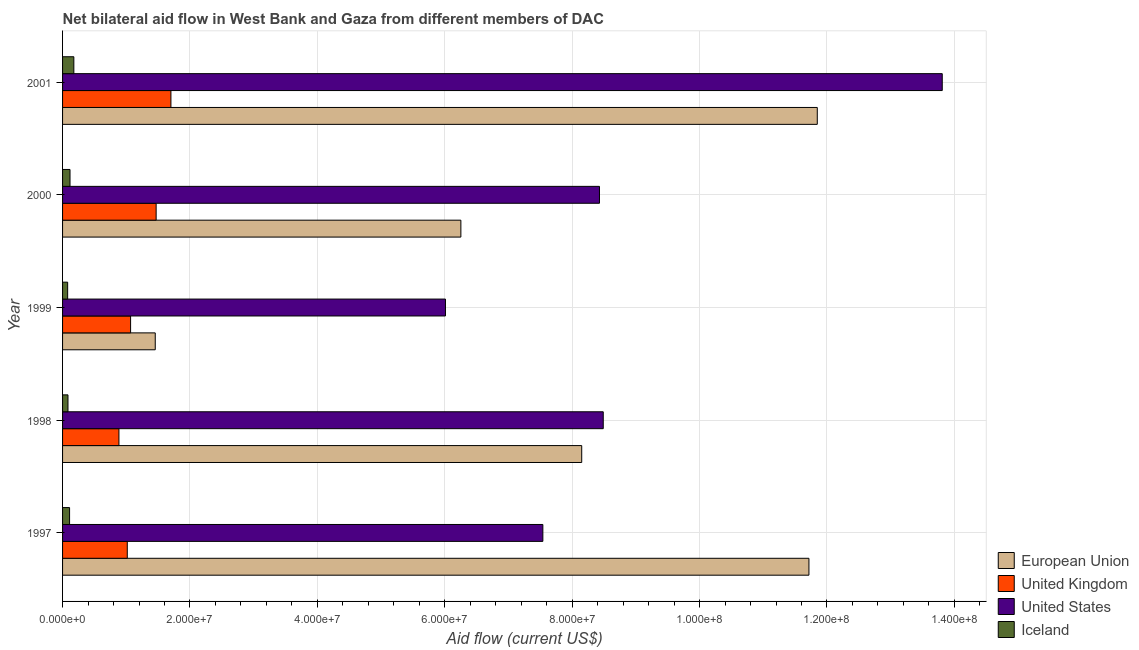In how many cases, is the number of bars for a given year not equal to the number of legend labels?
Keep it short and to the point. 0. What is the amount of aid given by us in 2000?
Provide a short and direct response. 8.43e+07. Across all years, what is the maximum amount of aid given by eu?
Make the answer very short. 1.18e+08. Across all years, what is the minimum amount of aid given by uk?
Make the answer very short. 8.85e+06. In which year was the amount of aid given by iceland maximum?
Keep it short and to the point. 2001. What is the total amount of aid given by uk in the graph?
Provide a succinct answer. 6.14e+07. What is the difference between the amount of aid given by eu in 1998 and that in 1999?
Provide a succinct answer. 6.70e+07. What is the difference between the amount of aid given by iceland in 2001 and the amount of aid given by eu in 1998?
Keep it short and to the point. -7.97e+07. What is the average amount of aid given by us per year?
Keep it short and to the point. 8.86e+07. In the year 1998, what is the difference between the amount of aid given by eu and amount of aid given by us?
Your response must be concise. -3.38e+06. What is the ratio of the amount of aid given by eu in 2000 to that in 2001?
Your response must be concise. 0.53. Is the amount of aid given by us in 2000 less than that in 2001?
Your answer should be compact. Yes. Is the difference between the amount of aid given by us in 1997 and 1998 greater than the difference between the amount of aid given by iceland in 1997 and 1998?
Make the answer very short. No. What is the difference between the highest and the second highest amount of aid given by eu?
Keep it short and to the point. 1.31e+06. What is the difference between the highest and the lowest amount of aid given by uk?
Offer a very short reply. 8.16e+06. Is the sum of the amount of aid given by uk in 1999 and 2000 greater than the maximum amount of aid given by us across all years?
Provide a short and direct response. No. What does the 2nd bar from the bottom in 1997 represents?
Give a very brief answer. United Kingdom. Is it the case that in every year, the sum of the amount of aid given by eu and amount of aid given by uk is greater than the amount of aid given by us?
Provide a short and direct response. No. How many bars are there?
Your answer should be very brief. 20. Are all the bars in the graph horizontal?
Provide a succinct answer. Yes. What is the difference between two consecutive major ticks on the X-axis?
Your answer should be very brief. 2.00e+07. Are the values on the major ticks of X-axis written in scientific E-notation?
Ensure brevity in your answer.  Yes. Does the graph contain any zero values?
Provide a short and direct response. No. Does the graph contain grids?
Provide a short and direct response. Yes. Where does the legend appear in the graph?
Your answer should be very brief. Bottom right. How are the legend labels stacked?
Keep it short and to the point. Vertical. What is the title of the graph?
Offer a very short reply. Net bilateral aid flow in West Bank and Gaza from different members of DAC. Does "Italy" appear as one of the legend labels in the graph?
Offer a terse response. No. What is the label or title of the Y-axis?
Your answer should be compact. Year. What is the Aid flow (current US$) in European Union in 1997?
Provide a short and direct response. 1.17e+08. What is the Aid flow (current US$) in United Kingdom in 1997?
Your response must be concise. 1.02e+07. What is the Aid flow (current US$) in United States in 1997?
Your answer should be compact. 7.54e+07. What is the Aid flow (current US$) of Iceland in 1997?
Keep it short and to the point. 1.10e+06. What is the Aid flow (current US$) in European Union in 1998?
Your answer should be very brief. 8.15e+07. What is the Aid flow (current US$) in United Kingdom in 1998?
Ensure brevity in your answer.  8.85e+06. What is the Aid flow (current US$) of United States in 1998?
Offer a very short reply. 8.49e+07. What is the Aid flow (current US$) of Iceland in 1998?
Keep it short and to the point. 8.50e+05. What is the Aid flow (current US$) of European Union in 1999?
Provide a succinct answer. 1.46e+07. What is the Aid flow (current US$) of United Kingdom in 1999?
Offer a very short reply. 1.07e+07. What is the Aid flow (current US$) of United States in 1999?
Provide a short and direct response. 6.01e+07. What is the Aid flow (current US$) of Iceland in 1999?
Offer a very short reply. 8.00e+05. What is the Aid flow (current US$) of European Union in 2000?
Offer a very short reply. 6.25e+07. What is the Aid flow (current US$) in United Kingdom in 2000?
Your answer should be compact. 1.47e+07. What is the Aid flow (current US$) in United States in 2000?
Offer a terse response. 8.43e+07. What is the Aid flow (current US$) of Iceland in 2000?
Provide a short and direct response. 1.17e+06. What is the Aid flow (current US$) of European Union in 2001?
Provide a short and direct response. 1.18e+08. What is the Aid flow (current US$) of United Kingdom in 2001?
Your answer should be very brief. 1.70e+07. What is the Aid flow (current US$) of United States in 2001?
Your answer should be compact. 1.38e+08. What is the Aid flow (current US$) of Iceland in 2001?
Make the answer very short. 1.77e+06. Across all years, what is the maximum Aid flow (current US$) of European Union?
Give a very brief answer. 1.18e+08. Across all years, what is the maximum Aid flow (current US$) of United Kingdom?
Your answer should be compact. 1.70e+07. Across all years, what is the maximum Aid flow (current US$) in United States?
Offer a very short reply. 1.38e+08. Across all years, what is the maximum Aid flow (current US$) of Iceland?
Offer a very short reply. 1.77e+06. Across all years, what is the minimum Aid flow (current US$) of European Union?
Provide a short and direct response. 1.46e+07. Across all years, what is the minimum Aid flow (current US$) in United Kingdom?
Your answer should be compact. 8.85e+06. Across all years, what is the minimum Aid flow (current US$) of United States?
Provide a short and direct response. 6.01e+07. What is the total Aid flow (current US$) of European Union in the graph?
Your answer should be compact. 3.94e+08. What is the total Aid flow (current US$) of United Kingdom in the graph?
Your response must be concise. 6.14e+07. What is the total Aid flow (current US$) of United States in the graph?
Make the answer very short. 4.43e+08. What is the total Aid flow (current US$) of Iceland in the graph?
Your answer should be compact. 5.69e+06. What is the difference between the Aid flow (current US$) of European Union in 1997 and that in 1998?
Your answer should be very brief. 3.57e+07. What is the difference between the Aid flow (current US$) in United Kingdom in 1997 and that in 1998?
Your answer should be very brief. 1.31e+06. What is the difference between the Aid flow (current US$) of United States in 1997 and that in 1998?
Keep it short and to the point. -9.48e+06. What is the difference between the Aid flow (current US$) in Iceland in 1997 and that in 1998?
Make the answer very short. 2.50e+05. What is the difference between the Aid flow (current US$) of European Union in 1997 and that in 1999?
Give a very brief answer. 1.03e+08. What is the difference between the Aid flow (current US$) of United Kingdom in 1997 and that in 1999?
Your response must be concise. -5.20e+05. What is the difference between the Aid flow (current US$) of United States in 1997 and that in 1999?
Provide a short and direct response. 1.53e+07. What is the difference between the Aid flow (current US$) of European Union in 1997 and that in 2000?
Your answer should be compact. 5.46e+07. What is the difference between the Aid flow (current US$) in United Kingdom in 1997 and that in 2000?
Provide a succinct answer. -4.53e+06. What is the difference between the Aid flow (current US$) of United States in 1997 and that in 2000?
Make the answer very short. -8.89e+06. What is the difference between the Aid flow (current US$) of European Union in 1997 and that in 2001?
Your answer should be very brief. -1.31e+06. What is the difference between the Aid flow (current US$) in United Kingdom in 1997 and that in 2001?
Your answer should be compact. -6.85e+06. What is the difference between the Aid flow (current US$) in United States in 1997 and that in 2001?
Offer a terse response. -6.27e+07. What is the difference between the Aid flow (current US$) of Iceland in 1997 and that in 2001?
Offer a terse response. -6.70e+05. What is the difference between the Aid flow (current US$) of European Union in 1998 and that in 1999?
Your answer should be compact. 6.70e+07. What is the difference between the Aid flow (current US$) of United Kingdom in 1998 and that in 1999?
Your response must be concise. -1.83e+06. What is the difference between the Aid flow (current US$) in United States in 1998 and that in 1999?
Keep it short and to the point. 2.48e+07. What is the difference between the Aid flow (current US$) in European Union in 1998 and that in 2000?
Ensure brevity in your answer.  1.90e+07. What is the difference between the Aid flow (current US$) of United Kingdom in 1998 and that in 2000?
Make the answer very short. -5.84e+06. What is the difference between the Aid flow (current US$) in United States in 1998 and that in 2000?
Give a very brief answer. 5.90e+05. What is the difference between the Aid flow (current US$) of Iceland in 1998 and that in 2000?
Give a very brief answer. -3.20e+05. What is the difference between the Aid flow (current US$) in European Union in 1998 and that in 2001?
Give a very brief answer. -3.70e+07. What is the difference between the Aid flow (current US$) in United Kingdom in 1998 and that in 2001?
Provide a short and direct response. -8.16e+06. What is the difference between the Aid flow (current US$) of United States in 1998 and that in 2001?
Give a very brief answer. -5.32e+07. What is the difference between the Aid flow (current US$) of Iceland in 1998 and that in 2001?
Your answer should be very brief. -9.20e+05. What is the difference between the Aid flow (current US$) in European Union in 1999 and that in 2000?
Your response must be concise. -4.80e+07. What is the difference between the Aid flow (current US$) of United Kingdom in 1999 and that in 2000?
Your answer should be very brief. -4.01e+06. What is the difference between the Aid flow (current US$) of United States in 1999 and that in 2000?
Make the answer very short. -2.42e+07. What is the difference between the Aid flow (current US$) of Iceland in 1999 and that in 2000?
Offer a very short reply. -3.70e+05. What is the difference between the Aid flow (current US$) of European Union in 1999 and that in 2001?
Give a very brief answer. -1.04e+08. What is the difference between the Aid flow (current US$) in United Kingdom in 1999 and that in 2001?
Provide a succinct answer. -6.33e+06. What is the difference between the Aid flow (current US$) of United States in 1999 and that in 2001?
Provide a succinct answer. -7.80e+07. What is the difference between the Aid flow (current US$) in Iceland in 1999 and that in 2001?
Keep it short and to the point. -9.70e+05. What is the difference between the Aid flow (current US$) in European Union in 2000 and that in 2001?
Your answer should be very brief. -5.60e+07. What is the difference between the Aid flow (current US$) in United Kingdom in 2000 and that in 2001?
Ensure brevity in your answer.  -2.32e+06. What is the difference between the Aid flow (current US$) of United States in 2000 and that in 2001?
Your response must be concise. -5.38e+07. What is the difference between the Aid flow (current US$) in Iceland in 2000 and that in 2001?
Your answer should be very brief. -6.00e+05. What is the difference between the Aid flow (current US$) of European Union in 1997 and the Aid flow (current US$) of United Kingdom in 1998?
Keep it short and to the point. 1.08e+08. What is the difference between the Aid flow (current US$) in European Union in 1997 and the Aid flow (current US$) in United States in 1998?
Your answer should be very brief. 3.23e+07. What is the difference between the Aid flow (current US$) in European Union in 1997 and the Aid flow (current US$) in Iceland in 1998?
Make the answer very short. 1.16e+08. What is the difference between the Aid flow (current US$) in United Kingdom in 1997 and the Aid flow (current US$) in United States in 1998?
Provide a short and direct response. -7.47e+07. What is the difference between the Aid flow (current US$) in United Kingdom in 1997 and the Aid flow (current US$) in Iceland in 1998?
Make the answer very short. 9.31e+06. What is the difference between the Aid flow (current US$) in United States in 1997 and the Aid flow (current US$) in Iceland in 1998?
Give a very brief answer. 7.46e+07. What is the difference between the Aid flow (current US$) in European Union in 1997 and the Aid flow (current US$) in United Kingdom in 1999?
Your answer should be very brief. 1.06e+08. What is the difference between the Aid flow (current US$) of European Union in 1997 and the Aid flow (current US$) of United States in 1999?
Make the answer very short. 5.71e+07. What is the difference between the Aid flow (current US$) of European Union in 1997 and the Aid flow (current US$) of Iceland in 1999?
Keep it short and to the point. 1.16e+08. What is the difference between the Aid flow (current US$) in United Kingdom in 1997 and the Aid flow (current US$) in United States in 1999?
Your answer should be very brief. -5.00e+07. What is the difference between the Aid flow (current US$) in United Kingdom in 1997 and the Aid flow (current US$) in Iceland in 1999?
Your response must be concise. 9.36e+06. What is the difference between the Aid flow (current US$) in United States in 1997 and the Aid flow (current US$) in Iceland in 1999?
Offer a very short reply. 7.46e+07. What is the difference between the Aid flow (current US$) in European Union in 1997 and the Aid flow (current US$) in United Kingdom in 2000?
Provide a succinct answer. 1.02e+08. What is the difference between the Aid flow (current US$) in European Union in 1997 and the Aid flow (current US$) in United States in 2000?
Make the answer very short. 3.29e+07. What is the difference between the Aid flow (current US$) of European Union in 1997 and the Aid flow (current US$) of Iceland in 2000?
Your answer should be compact. 1.16e+08. What is the difference between the Aid flow (current US$) of United Kingdom in 1997 and the Aid flow (current US$) of United States in 2000?
Give a very brief answer. -7.41e+07. What is the difference between the Aid flow (current US$) in United Kingdom in 1997 and the Aid flow (current US$) in Iceland in 2000?
Provide a succinct answer. 8.99e+06. What is the difference between the Aid flow (current US$) in United States in 1997 and the Aid flow (current US$) in Iceland in 2000?
Provide a succinct answer. 7.42e+07. What is the difference between the Aid flow (current US$) of European Union in 1997 and the Aid flow (current US$) of United Kingdom in 2001?
Make the answer very short. 1.00e+08. What is the difference between the Aid flow (current US$) of European Union in 1997 and the Aid flow (current US$) of United States in 2001?
Make the answer very short. -2.09e+07. What is the difference between the Aid flow (current US$) in European Union in 1997 and the Aid flow (current US$) in Iceland in 2001?
Give a very brief answer. 1.15e+08. What is the difference between the Aid flow (current US$) of United Kingdom in 1997 and the Aid flow (current US$) of United States in 2001?
Provide a succinct answer. -1.28e+08. What is the difference between the Aid flow (current US$) in United Kingdom in 1997 and the Aid flow (current US$) in Iceland in 2001?
Ensure brevity in your answer.  8.39e+06. What is the difference between the Aid flow (current US$) of United States in 1997 and the Aid flow (current US$) of Iceland in 2001?
Provide a succinct answer. 7.36e+07. What is the difference between the Aid flow (current US$) in European Union in 1998 and the Aid flow (current US$) in United Kingdom in 1999?
Your answer should be very brief. 7.08e+07. What is the difference between the Aid flow (current US$) in European Union in 1998 and the Aid flow (current US$) in United States in 1999?
Ensure brevity in your answer.  2.14e+07. What is the difference between the Aid flow (current US$) in European Union in 1998 and the Aid flow (current US$) in Iceland in 1999?
Ensure brevity in your answer.  8.07e+07. What is the difference between the Aid flow (current US$) of United Kingdom in 1998 and the Aid flow (current US$) of United States in 1999?
Provide a succinct answer. -5.13e+07. What is the difference between the Aid flow (current US$) in United Kingdom in 1998 and the Aid flow (current US$) in Iceland in 1999?
Your answer should be very brief. 8.05e+06. What is the difference between the Aid flow (current US$) in United States in 1998 and the Aid flow (current US$) in Iceland in 1999?
Make the answer very short. 8.41e+07. What is the difference between the Aid flow (current US$) of European Union in 1998 and the Aid flow (current US$) of United Kingdom in 2000?
Ensure brevity in your answer.  6.68e+07. What is the difference between the Aid flow (current US$) in European Union in 1998 and the Aid flow (current US$) in United States in 2000?
Provide a short and direct response. -2.79e+06. What is the difference between the Aid flow (current US$) in European Union in 1998 and the Aid flow (current US$) in Iceland in 2000?
Make the answer very short. 8.03e+07. What is the difference between the Aid flow (current US$) of United Kingdom in 1998 and the Aid flow (current US$) of United States in 2000?
Make the answer very short. -7.54e+07. What is the difference between the Aid flow (current US$) of United Kingdom in 1998 and the Aid flow (current US$) of Iceland in 2000?
Your response must be concise. 7.68e+06. What is the difference between the Aid flow (current US$) in United States in 1998 and the Aid flow (current US$) in Iceland in 2000?
Keep it short and to the point. 8.37e+07. What is the difference between the Aid flow (current US$) of European Union in 1998 and the Aid flow (current US$) of United Kingdom in 2001?
Provide a short and direct response. 6.45e+07. What is the difference between the Aid flow (current US$) in European Union in 1998 and the Aid flow (current US$) in United States in 2001?
Your answer should be very brief. -5.66e+07. What is the difference between the Aid flow (current US$) of European Union in 1998 and the Aid flow (current US$) of Iceland in 2001?
Your answer should be compact. 7.97e+07. What is the difference between the Aid flow (current US$) of United Kingdom in 1998 and the Aid flow (current US$) of United States in 2001?
Give a very brief answer. -1.29e+08. What is the difference between the Aid flow (current US$) in United Kingdom in 1998 and the Aid flow (current US$) in Iceland in 2001?
Your answer should be very brief. 7.08e+06. What is the difference between the Aid flow (current US$) of United States in 1998 and the Aid flow (current US$) of Iceland in 2001?
Make the answer very short. 8.31e+07. What is the difference between the Aid flow (current US$) of European Union in 1999 and the Aid flow (current US$) of United Kingdom in 2000?
Ensure brevity in your answer.  -1.40e+05. What is the difference between the Aid flow (current US$) of European Union in 1999 and the Aid flow (current US$) of United States in 2000?
Your answer should be compact. -6.97e+07. What is the difference between the Aid flow (current US$) of European Union in 1999 and the Aid flow (current US$) of Iceland in 2000?
Make the answer very short. 1.34e+07. What is the difference between the Aid flow (current US$) in United Kingdom in 1999 and the Aid flow (current US$) in United States in 2000?
Offer a terse response. -7.36e+07. What is the difference between the Aid flow (current US$) of United Kingdom in 1999 and the Aid flow (current US$) of Iceland in 2000?
Offer a very short reply. 9.51e+06. What is the difference between the Aid flow (current US$) of United States in 1999 and the Aid flow (current US$) of Iceland in 2000?
Provide a short and direct response. 5.89e+07. What is the difference between the Aid flow (current US$) in European Union in 1999 and the Aid flow (current US$) in United Kingdom in 2001?
Provide a succinct answer. -2.46e+06. What is the difference between the Aid flow (current US$) of European Union in 1999 and the Aid flow (current US$) of United States in 2001?
Offer a terse response. -1.24e+08. What is the difference between the Aid flow (current US$) of European Union in 1999 and the Aid flow (current US$) of Iceland in 2001?
Offer a terse response. 1.28e+07. What is the difference between the Aid flow (current US$) in United Kingdom in 1999 and the Aid flow (current US$) in United States in 2001?
Your answer should be compact. -1.27e+08. What is the difference between the Aid flow (current US$) in United Kingdom in 1999 and the Aid flow (current US$) in Iceland in 2001?
Provide a short and direct response. 8.91e+06. What is the difference between the Aid flow (current US$) in United States in 1999 and the Aid flow (current US$) in Iceland in 2001?
Offer a terse response. 5.83e+07. What is the difference between the Aid flow (current US$) in European Union in 2000 and the Aid flow (current US$) in United Kingdom in 2001?
Your response must be concise. 4.55e+07. What is the difference between the Aid flow (current US$) of European Union in 2000 and the Aid flow (current US$) of United States in 2001?
Keep it short and to the point. -7.56e+07. What is the difference between the Aid flow (current US$) of European Union in 2000 and the Aid flow (current US$) of Iceland in 2001?
Keep it short and to the point. 6.08e+07. What is the difference between the Aid flow (current US$) of United Kingdom in 2000 and the Aid flow (current US$) of United States in 2001?
Make the answer very short. -1.23e+08. What is the difference between the Aid flow (current US$) of United Kingdom in 2000 and the Aid flow (current US$) of Iceland in 2001?
Your answer should be very brief. 1.29e+07. What is the difference between the Aid flow (current US$) of United States in 2000 and the Aid flow (current US$) of Iceland in 2001?
Offer a terse response. 8.25e+07. What is the average Aid flow (current US$) in European Union per year?
Offer a terse response. 7.88e+07. What is the average Aid flow (current US$) of United Kingdom per year?
Your response must be concise. 1.23e+07. What is the average Aid flow (current US$) of United States per year?
Your answer should be compact. 8.86e+07. What is the average Aid flow (current US$) of Iceland per year?
Your response must be concise. 1.14e+06. In the year 1997, what is the difference between the Aid flow (current US$) in European Union and Aid flow (current US$) in United Kingdom?
Give a very brief answer. 1.07e+08. In the year 1997, what is the difference between the Aid flow (current US$) in European Union and Aid flow (current US$) in United States?
Provide a short and direct response. 4.18e+07. In the year 1997, what is the difference between the Aid flow (current US$) in European Union and Aid flow (current US$) in Iceland?
Provide a short and direct response. 1.16e+08. In the year 1997, what is the difference between the Aid flow (current US$) in United Kingdom and Aid flow (current US$) in United States?
Offer a terse response. -6.52e+07. In the year 1997, what is the difference between the Aid flow (current US$) of United Kingdom and Aid flow (current US$) of Iceland?
Offer a very short reply. 9.06e+06. In the year 1997, what is the difference between the Aid flow (current US$) in United States and Aid flow (current US$) in Iceland?
Ensure brevity in your answer.  7.43e+07. In the year 1998, what is the difference between the Aid flow (current US$) of European Union and Aid flow (current US$) of United Kingdom?
Your response must be concise. 7.26e+07. In the year 1998, what is the difference between the Aid flow (current US$) in European Union and Aid flow (current US$) in United States?
Ensure brevity in your answer.  -3.38e+06. In the year 1998, what is the difference between the Aid flow (current US$) in European Union and Aid flow (current US$) in Iceland?
Your response must be concise. 8.06e+07. In the year 1998, what is the difference between the Aid flow (current US$) in United Kingdom and Aid flow (current US$) in United States?
Keep it short and to the point. -7.60e+07. In the year 1998, what is the difference between the Aid flow (current US$) of United States and Aid flow (current US$) of Iceland?
Offer a very short reply. 8.40e+07. In the year 1999, what is the difference between the Aid flow (current US$) of European Union and Aid flow (current US$) of United Kingdom?
Keep it short and to the point. 3.87e+06. In the year 1999, what is the difference between the Aid flow (current US$) of European Union and Aid flow (current US$) of United States?
Your answer should be very brief. -4.56e+07. In the year 1999, what is the difference between the Aid flow (current US$) of European Union and Aid flow (current US$) of Iceland?
Provide a succinct answer. 1.38e+07. In the year 1999, what is the difference between the Aid flow (current US$) in United Kingdom and Aid flow (current US$) in United States?
Offer a very short reply. -4.94e+07. In the year 1999, what is the difference between the Aid flow (current US$) in United Kingdom and Aid flow (current US$) in Iceland?
Provide a short and direct response. 9.88e+06. In the year 1999, what is the difference between the Aid flow (current US$) of United States and Aid flow (current US$) of Iceland?
Ensure brevity in your answer.  5.93e+07. In the year 2000, what is the difference between the Aid flow (current US$) in European Union and Aid flow (current US$) in United Kingdom?
Your answer should be very brief. 4.78e+07. In the year 2000, what is the difference between the Aid flow (current US$) in European Union and Aid flow (current US$) in United States?
Your answer should be compact. -2.18e+07. In the year 2000, what is the difference between the Aid flow (current US$) in European Union and Aid flow (current US$) in Iceland?
Make the answer very short. 6.14e+07. In the year 2000, what is the difference between the Aid flow (current US$) in United Kingdom and Aid flow (current US$) in United States?
Your response must be concise. -6.96e+07. In the year 2000, what is the difference between the Aid flow (current US$) of United Kingdom and Aid flow (current US$) of Iceland?
Your answer should be compact. 1.35e+07. In the year 2000, what is the difference between the Aid flow (current US$) in United States and Aid flow (current US$) in Iceland?
Offer a terse response. 8.31e+07. In the year 2001, what is the difference between the Aid flow (current US$) of European Union and Aid flow (current US$) of United Kingdom?
Ensure brevity in your answer.  1.01e+08. In the year 2001, what is the difference between the Aid flow (current US$) in European Union and Aid flow (current US$) in United States?
Your response must be concise. -1.96e+07. In the year 2001, what is the difference between the Aid flow (current US$) in European Union and Aid flow (current US$) in Iceland?
Offer a very short reply. 1.17e+08. In the year 2001, what is the difference between the Aid flow (current US$) of United Kingdom and Aid flow (current US$) of United States?
Provide a succinct answer. -1.21e+08. In the year 2001, what is the difference between the Aid flow (current US$) of United Kingdom and Aid flow (current US$) of Iceland?
Offer a terse response. 1.52e+07. In the year 2001, what is the difference between the Aid flow (current US$) of United States and Aid flow (current US$) of Iceland?
Provide a short and direct response. 1.36e+08. What is the ratio of the Aid flow (current US$) of European Union in 1997 to that in 1998?
Your answer should be very brief. 1.44. What is the ratio of the Aid flow (current US$) of United Kingdom in 1997 to that in 1998?
Give a very brief answer. 1.15. What is the ratio of the Aid flow (current US$) in United States in 1997 to that in 1998?
Ensure brevity in your answer.  0.89. What is the ratio of the Aid flow (current US$) in Iceland in 1997 to that in 1998?
Your answer should be compact. 1.29. What is the ratio of the Aid flow (current US$) of European Union in 1997 to that in 1999?
Provide a succinct answer. 8.05. What is the ratio of the Aid flow (current US$) of United Kingdom in 1997 to that in 1999?
Your answer should be very brief. 0.95. What is the ratio of the Aid flow (current US$) of United States in 1997 to that in 1999?
Your answer should be compact. 1.25. What is the ratio of the Aid flow (current US$) of Iceland in 1997 to that in 1999?
Make the answer very short. 1.38. What is the ratio of the Aid flow (current US$) of European Union in 1997 to that in 2000?
Your answer should be very brief. 1.87. What is the ratio of the Aid flow (current US$) in United Kingdom in 1997 to that in 2000?
Your answer should be very brief. 0.69. What is the ratio of the Aid flow (current US$) in United States in 1997 to that in 2000?
Your response must be concise. 0.89. What is the ratio of the Aid flow (current US$) of Iceland in 1997 to that in 2000?
Your answer should be compact. 0.94. What is the ratio of the Aid flow (current US$) in European Union in 1997 to that in 2001?
Your answer should be compact. 0.99. What is the ratio of the Aid flow (current US$) of United Kingdom in 1997 to that in 2001?
Give a very brief answer. 0.6. What is the ratio of the Aid flow (current US$) of United States in 1997 to that in 2001?
Provide a short and direct response. 0.55. What is the ratio of the Aid flow (current US$) in Iceland in 1997 to that in 2001?
Give a very brief answer. 0.62. What is the ratio of the Aid flow (current US$) of European Union in 1998 to that in 1999?
Your answer should be compact. 5.6. What is the ratio of the Aid flow (current US$) of United Kingdom in 1998 to that in 1999?
Give a very brief answer. 0.83. What is the ratio of the Aid flow (current US$) in United States in 1998 to that in 1999?
Make the answer very short. 1.41. What is the ratio of the Aid flow (current US$) of European Union in 1998 to that in 2000?
Offer a terse response. 1.3. What is the ratio of the Aid flow (current US$) in United Kingdom in 1998 to that in 2000?
Keep it short and to the point. 0.6. What is the ratio of the Aid flow (current US$) of United States in 1998 to that in 2000?
Your answer should be compact. 1.01. What is the ratio of the Aid flow (current US$) of Iceland in 1998 to that in 2000?
Give a very brief answer. 0.73. What is the ratio of the Aid flow (current US$) of European Union in 1998 to that in 2001?
Offer a terse response. 0.69. What is the ratio of the Aid flow (current US$) of United Kingdom in 1998 to that in 2001?
Give a very brief answer. 0.52. What is the ratio of the Aid flow (current US$) in United States in 1998 to that in 2001?
Give a very brief answer. 0.61. What is the ratio of the Aid flow (current US$) in Iceland in 1998 to that in 2001?
Your answer should be compact. 0.48. What is the ratio of the Aid flow (current US$) in European Union in 1999 to that in 2000?
Offer a terse response. 0.23. What is the ratio of the Aid flow (current US$) in United Kingdom in 1999 to that in 2000?
Provide a succinct answer. 0.73. What is the ratio of the Aid flow (current US$) in United States in 1999 to that in 2000?
Ensure brevity in your answer.  0.71. What is the ratio of the Aid flow (current US$) of Iceland in 1999 to that in 2000?
Offer a terse response. 0.68. What is the ratio of the Aid flow (current US$) of European Union in 1999 to that in 2001?
Offer a very short reply. 0.12. What is the ratio of the Aid flow (current US$) of United Kingdom in 1999 to that in 2001?
Give a very brief answer. 0.63. What is the ratio of the Aid flow (current US$) of United States in 1999 to that in 2001?
Your answer should be compact. 0.44. What is the ratio of the Aid flow (current US$) in Iceland in 1999 to that in 2001?
Your response must be concise. 0.45. What is the ratio of the Aid flow (current US$) of European Union in 2000 to that in 2001?
Your answer should be compact. 0.53. What is the ratio of the Aid flow (current US$) in United Kingdom in 2000 to that in 2001?
Offer a very short reply. 0.86. What is the ratio of the Aid flow (current US$) of United States in 2000 to that in 2001?
Make the answer very short. 0.61. What is the ratio of the Aid flow (current US$) of Iceland in 2000 to that in 2001?
Make the answer very short. 0.66. What is the difference between the highest and the second highest Aid flow (current US$) of European Union?
Ensure brevity in your answer.  1.31e+06. What is the difference between the highest and the second highest Aid flow (current US$) in United Kingdom?
Your answer should be compact. 2.32e+06. What is the difference between the highest and the second highest Aid flow (current US$) in United States?
Your response must be concise. 5.32e+07. What is the difference between the highest and the second highest Aid flow (current US$) in Iceland?
Your answer should be very brief. 6.00e+05. What is the difference between the highest and the lowest Aid flow (current US$) in European Union?
Your response must be concise. 1.04e+08. What is the difference between the highest and the lowest Aid flow (current US$) of United Kingdom?
Keep it short and to the point. 8.16e+06. What is the difference between the highest and the lowest Aid flow (current US$) of United States?
Ensure brevity in your answer.  7.80e+07. What is the difference between the highest and the lowest Aid flow (current US$) of Iceland?
Give a very brief answer. 9.70e+05. 